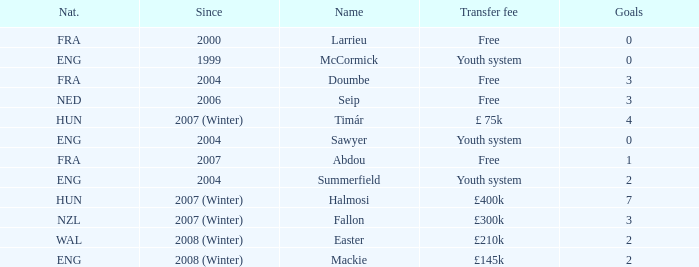Which nationality does the player with a £400k transfer fee possess? HUN. 